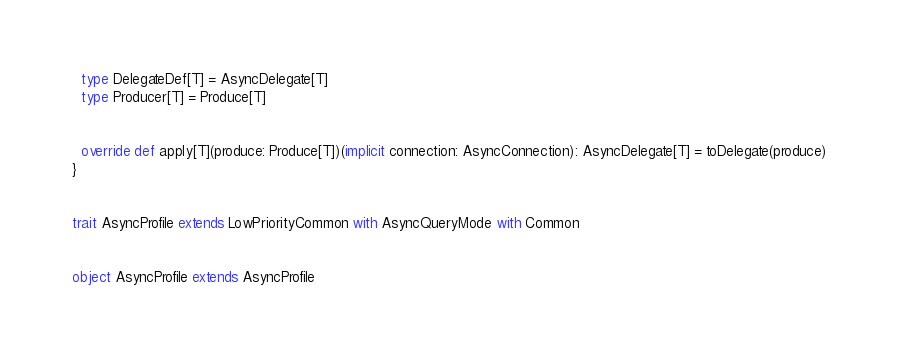<code> <loc_0><loc_0><loc_500><loc_500><_Scala_>
  type DelegateDef[T] = AsyncDelegate[T]
  type Producer[T] = Produce[T]


  override def apply[T](produce: Produce[T])(implicit connection: AsyncConnection): AsyncDelegate[T] = toDelegate(produce)
}


trait AsyncProfile extends LowPriorityCommon with AsyncQueryMode with Common


object AsyncProfile extends AsyncProfile</code> 